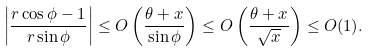<formula> <loc_0><loc_0><loc_500><loc_500>\left | \frac { r \cos \phi - 1 } { r \sin \phi } \right | \leq O \left ( \frac { \theta + x } { \sin \phi } \right ) \leq O \left ( \frac { \theta + x } { \sqrt { x } } \right ) \leq O ( 1 ) .</formula> 